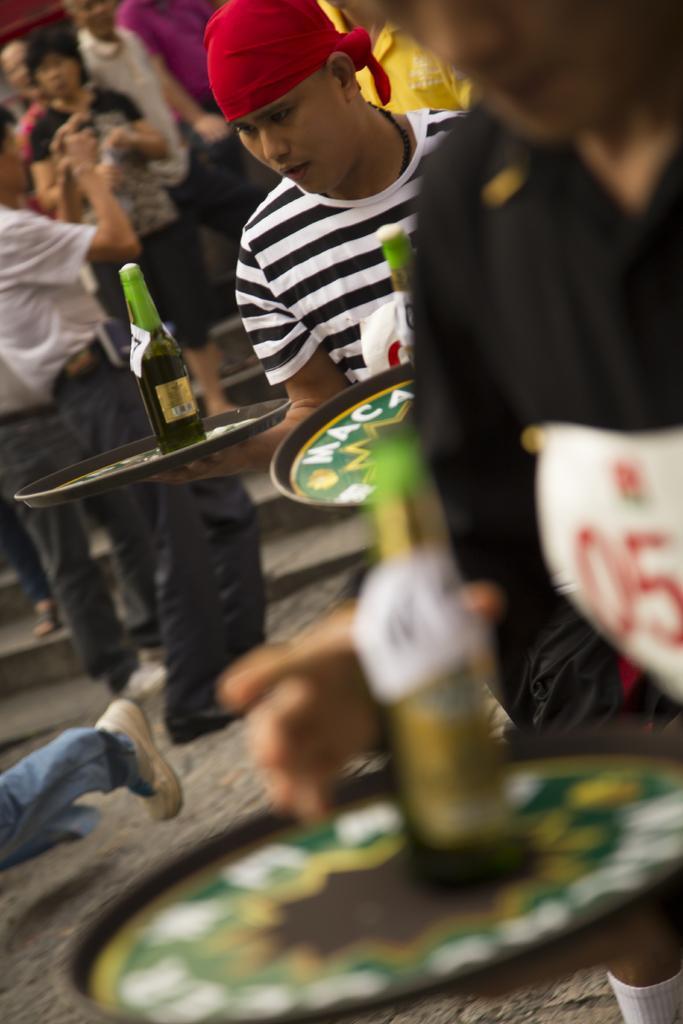Could you give a brief overview of what you see in this image? In this image we can see persons standing on the ground and some are carrying beverage bottles in trays on their hands. 